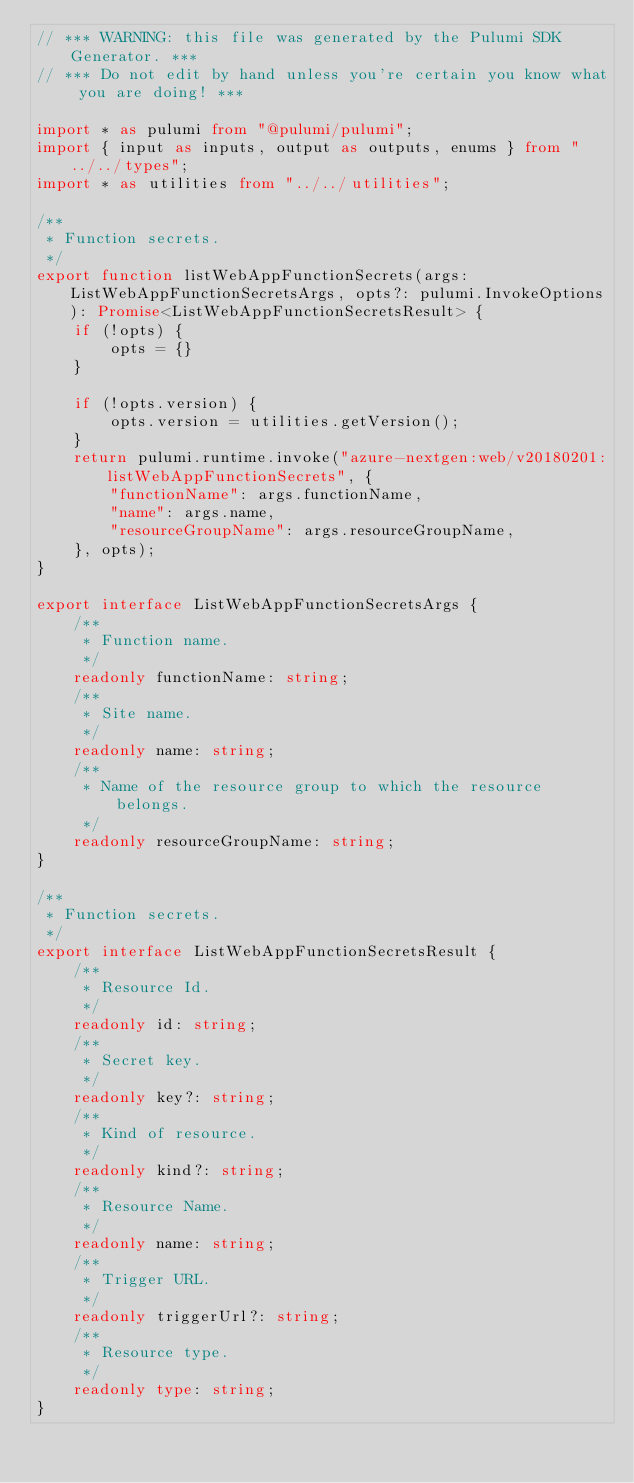Convert code to text. <code><loc_0><loc_0><loc_500><loc_500><_TypeScript_>// *** WARNING: this file was generated by the Pulumi SDK Generator. ***
// *** Do not edit by hand unless you're certain you know what you are doing! ***

import * as pulumi from "@pulumi/pulumi";
import { input as inputs, output as outputs, enums } from "../../types";
import * as utilities from "../../utilities";

/**
 * Function secrets.
 */
export function listWebAppFunctionSecrets(args: ListWebAppFunctionSecretsArgs, opts?: pulumi.InvokeOptions): Promise<ListWebAppFunctionSecretsResult> {
    if (!opts) {
        opts = {}
    }

    if (!opts.version) {
        opts.version = utilities.getVersion();
    }
    return pulumi.runtime.invoke("azure-nextgen:web/v20180201:listWebAppFunctionSecrets", {
        "functionName": args.functionName,
        "name": args.name,
        "resourceGroupName": args.resourceGroupName,
    }, opts);
}

export interface ListWebAppFunctionSecretsArgs {
    /**
     * Function name.
     */
    readonly functionName: string;
    /**
     * Site name.
     */
    readonly name: string;
    /**
     * Name of the resource group to which the resource belongs.
     */
    readonly resourceGroupName: string;
}

/**
 * Function secrets.
 */
export interface ListWebAppFunctionSecretsResult {
    /**
     * Resource Id.
     */
    readonly id: string;
    /**
     * Secret key.
     */
    readonly key?: string;
    /**
     * Kind of resource.
     */
    readonly kind?: string;
    /**
     * Resource Name.
     */
    readonly name: string;
    /**
     * Trigger URL.
     */
    readonly triggerUrl?: string;
    /**
     * Resource type.
     */
    readonly type: string;
}
</code> 